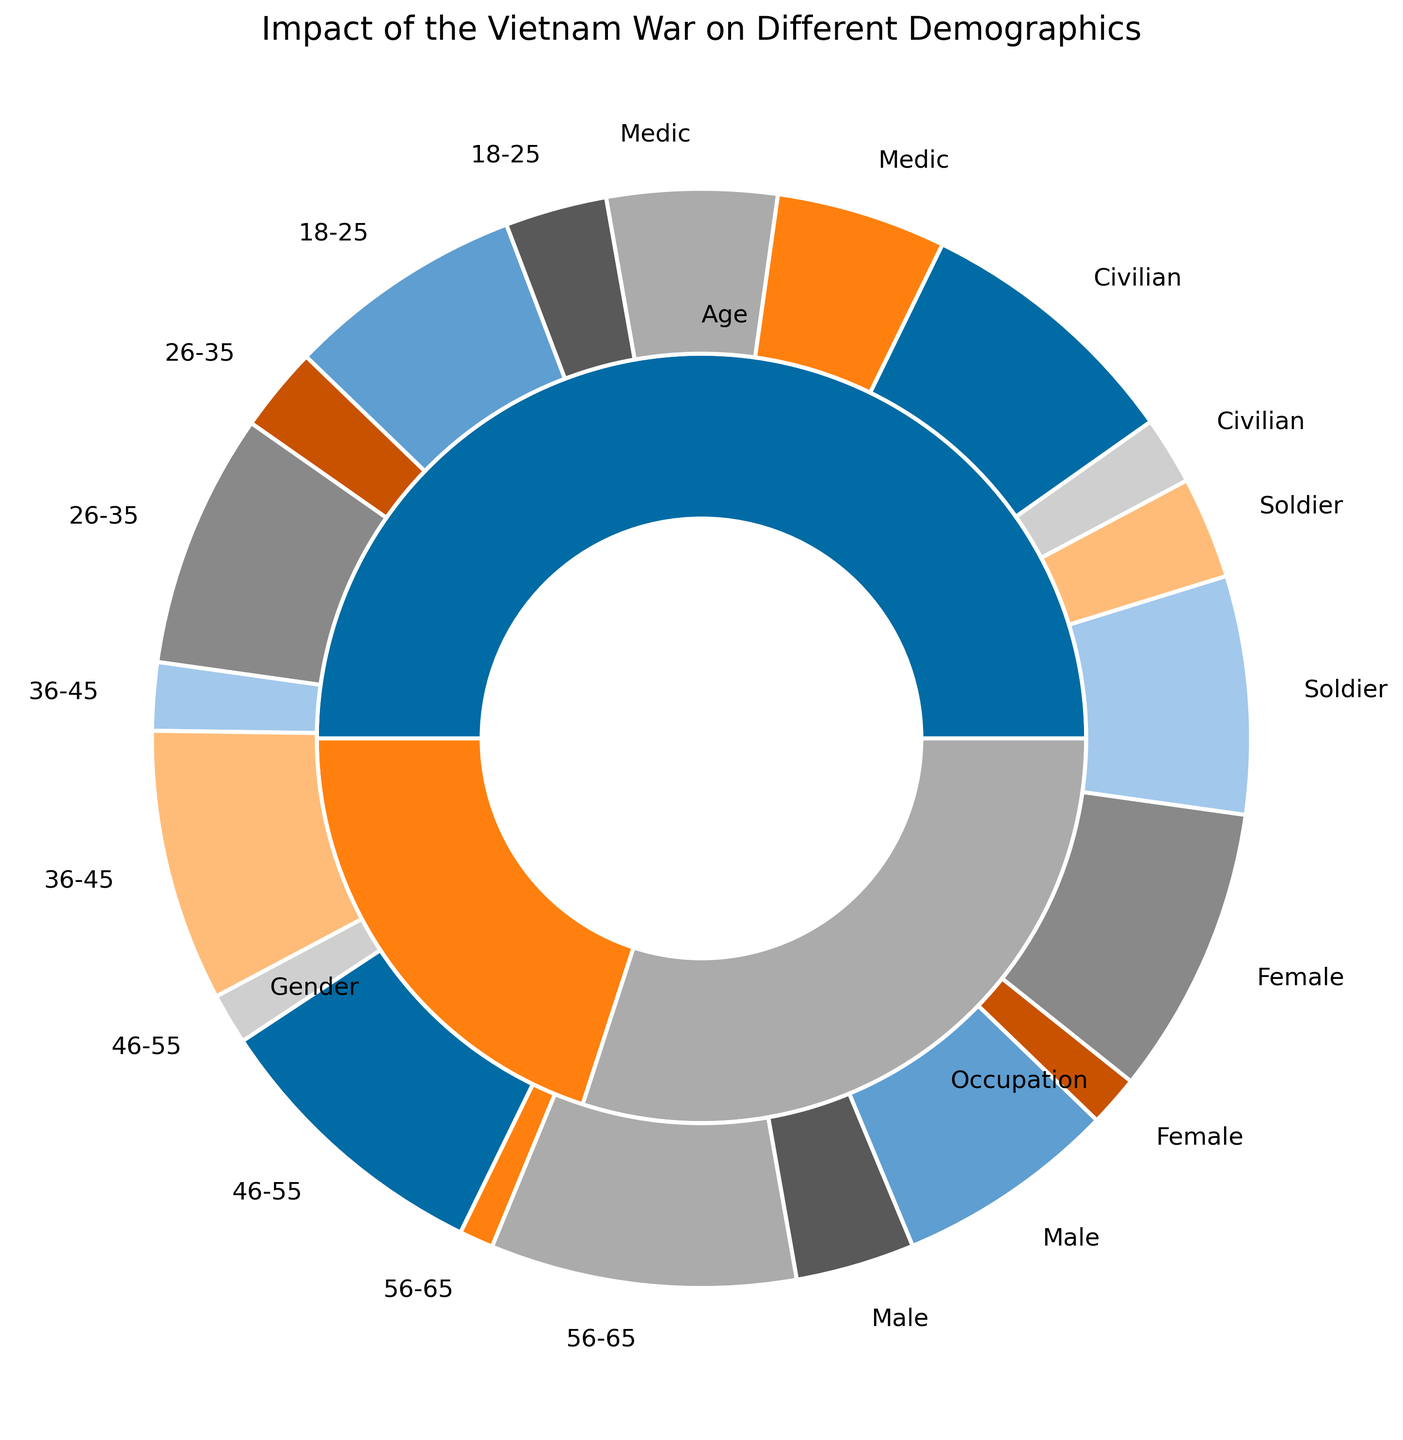What is the percentage of males who were affected by the Vietnam War? The outer circle labeled "Gender" has a section labeled "Male" in the inner circle, with a portion marked "Yes" for affected. This portion is 35%.
Answer: 35% Which occupation had the highest percentage of people affected by the Vietnam War? The outer circle labeled "Occupation" contains sections for different occupations in the inner circle. The "Soldier" section with "Yes" markings shows the highest value at 70%.
Answer: Soldier Compare the percentages of the youngest and oldest age groups affected by the Vietnam War. The inner sections under the "Age" category show "18-25" and "56-65." The "18-25" group has 30% affected, whereas the "56-65" group has 10% affected. 30% is greater than 10%.
Answer: 30% > 10% What is the total percentage of people affected by the Vietnam War across all age groups? Sum the percentages of "Yes" under "Age": 30% (18-25) + 25% (26-35) + 20% (36-45) + 15% (46-55) + 10% (56-65). The total is 100%.
Answer: 100% How does the percentage of affected females compare to affected males? The "Gender" category shows 15% of females affected and 35% males affected. 35% is more than 15%.
Answer: 35% > 15% What is the percentage difference between affected medics and civilians? Under "Occupation," "Medic" has 50% affected, and "Civilian" has 20% affected. The percentage difference is 50% - 20% = 30%.
Answer: 30% Which age group has the lowest percentage of people affected by the Vietnam War? Under the "Age" category, the "56-65" group shows the lowest percentage affected at 10%.
Answer: 56-65 How does the percentage of affected soldiers compare to the percentage of affected civilians? The "Occupation" section shows 70% soldiers affected and 20% civilians affected. 70% is greater than 20%.
Answer: 70% > 20% What is the combined percentage of affected males and females? Sum the percentages of "Yes" under "Gender": 35% (Male) + 15% (Female) = 50%.
Answer: 50% In which demographic does the smallest subgroup have the highest percentage of people affected by the Vietnam War? Under "Occupation," Medics have the smallest subgroup with 50% affected, the highest among the smallest subgroup in other demographics.
Answer: Medic 